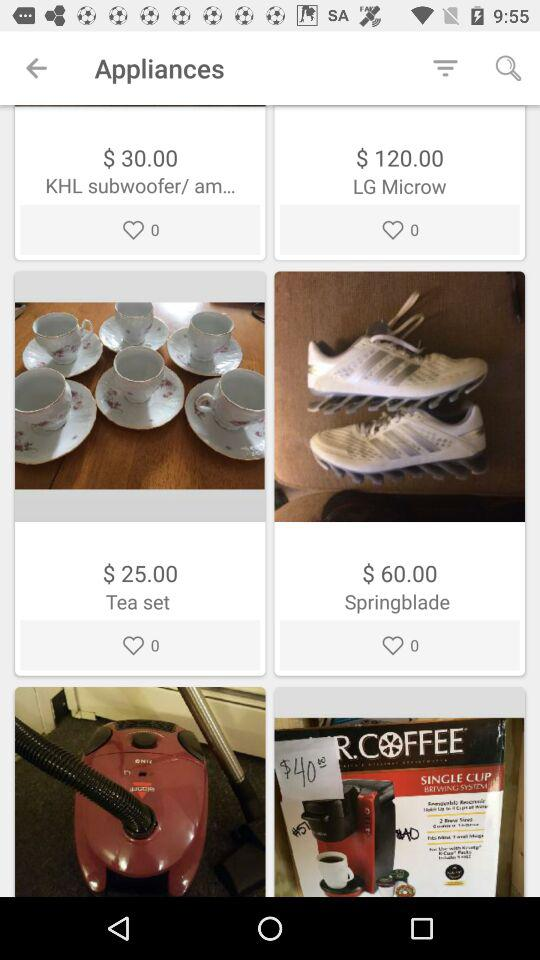What is the price of the Springblade? The price of the Springblade is $60. 